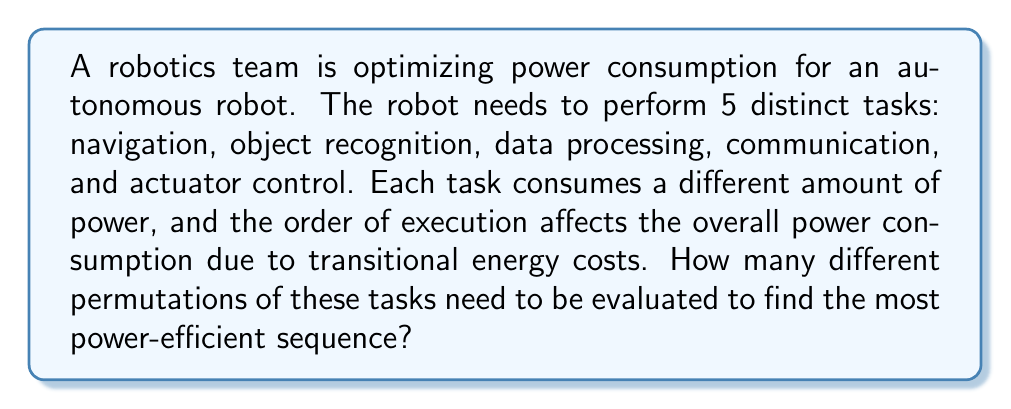Provide a solution to this math problem. To solve this problem, we need to understand the concept of permutations. A permutation is an arrangement of objects where order matters. In this case, we have 5 distinct tasks, and we need to arrange all of them in different orders.

The formula for calculating the number of permutations of n distinct objects is:

$$P(n) = n!$$

Where $n!$ represents the factorial of n.

In our case, $n = 5$ (the number of distinct tasks).

Therefore, we calculate:

$$P(5) = 5!$$

$$5! = 5 \times 4 \times 3 \times 2 \times 1 = 120$$

This means that there are 120 different ways to arrange these 5 tasks.

Each of these 120 permutations represents a unique sequence of tasks that the robot could perform. The robotics team would need to evaluate the power consumption for each of these sequences to determine which one is the most efficient.

It's worth noting that in a real-world scenario, the team might use algorithms or heuristics to optimize this process rather than exhaustively checking all permutations, especially if the number of tasks were to increase significantly.
Answer: 120 permutations 